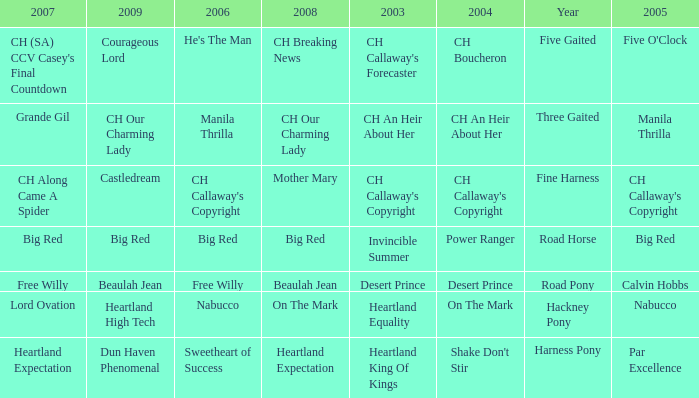What is the 2008 for the 2009 ch our charming lady? CH Our Charming Lady. 